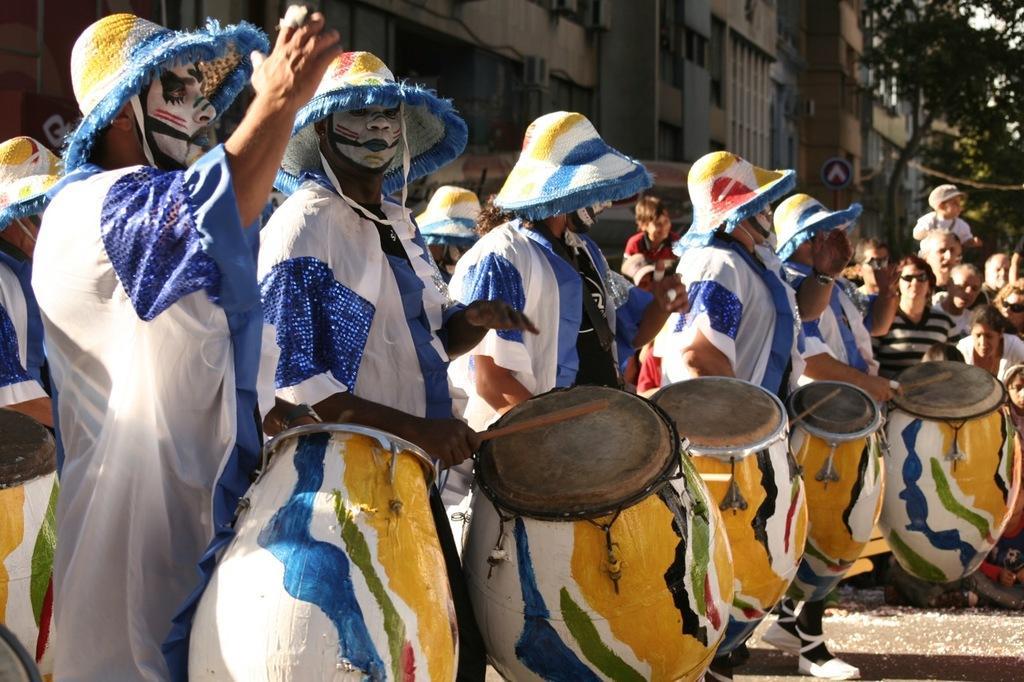Describe this image in one or two sentences. In this image, we can see some people standing and they are holding wooden music, drums, we can see trees on the right side, we can see some buildings. 